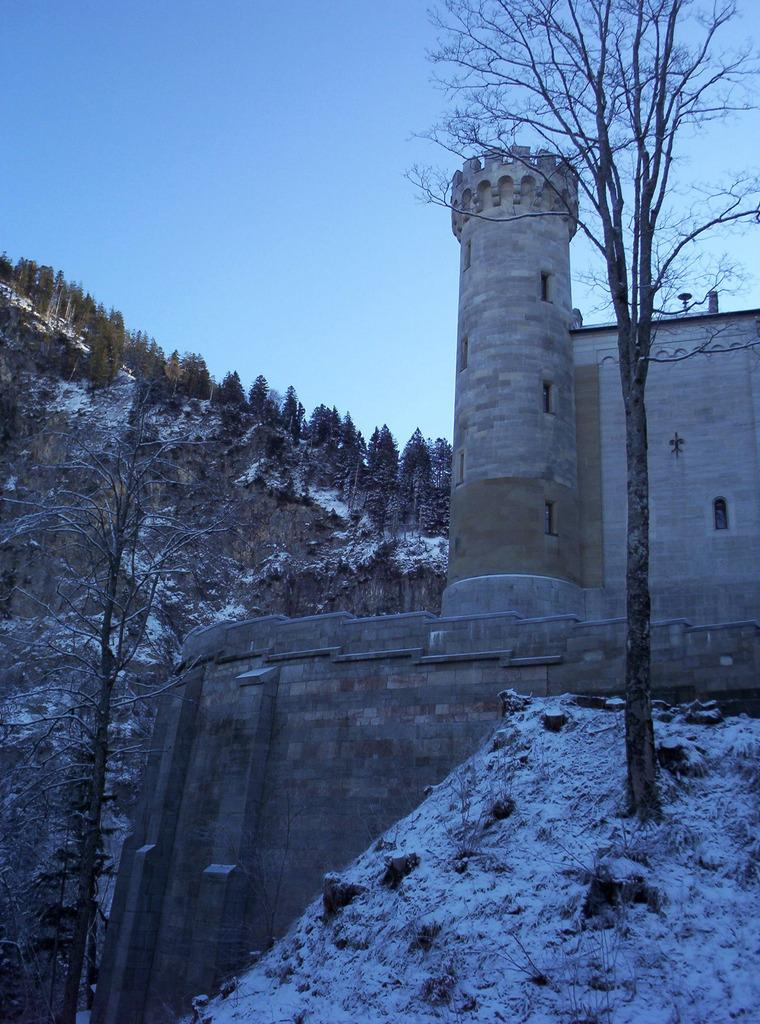What type of structure is present in the image? There is a fort in the image. What type of vegetation can be seen in the image? There are trees in the image. What is the weather like in the image? There is snow visible in the image, indicating a cold climate. What can be seen in the background of the image? The sky is visible in the background of the image. What type of bun is being served for the meal in the image? There is no meal or bun present in the image; it features a fort, trees, snow, and the sky. 